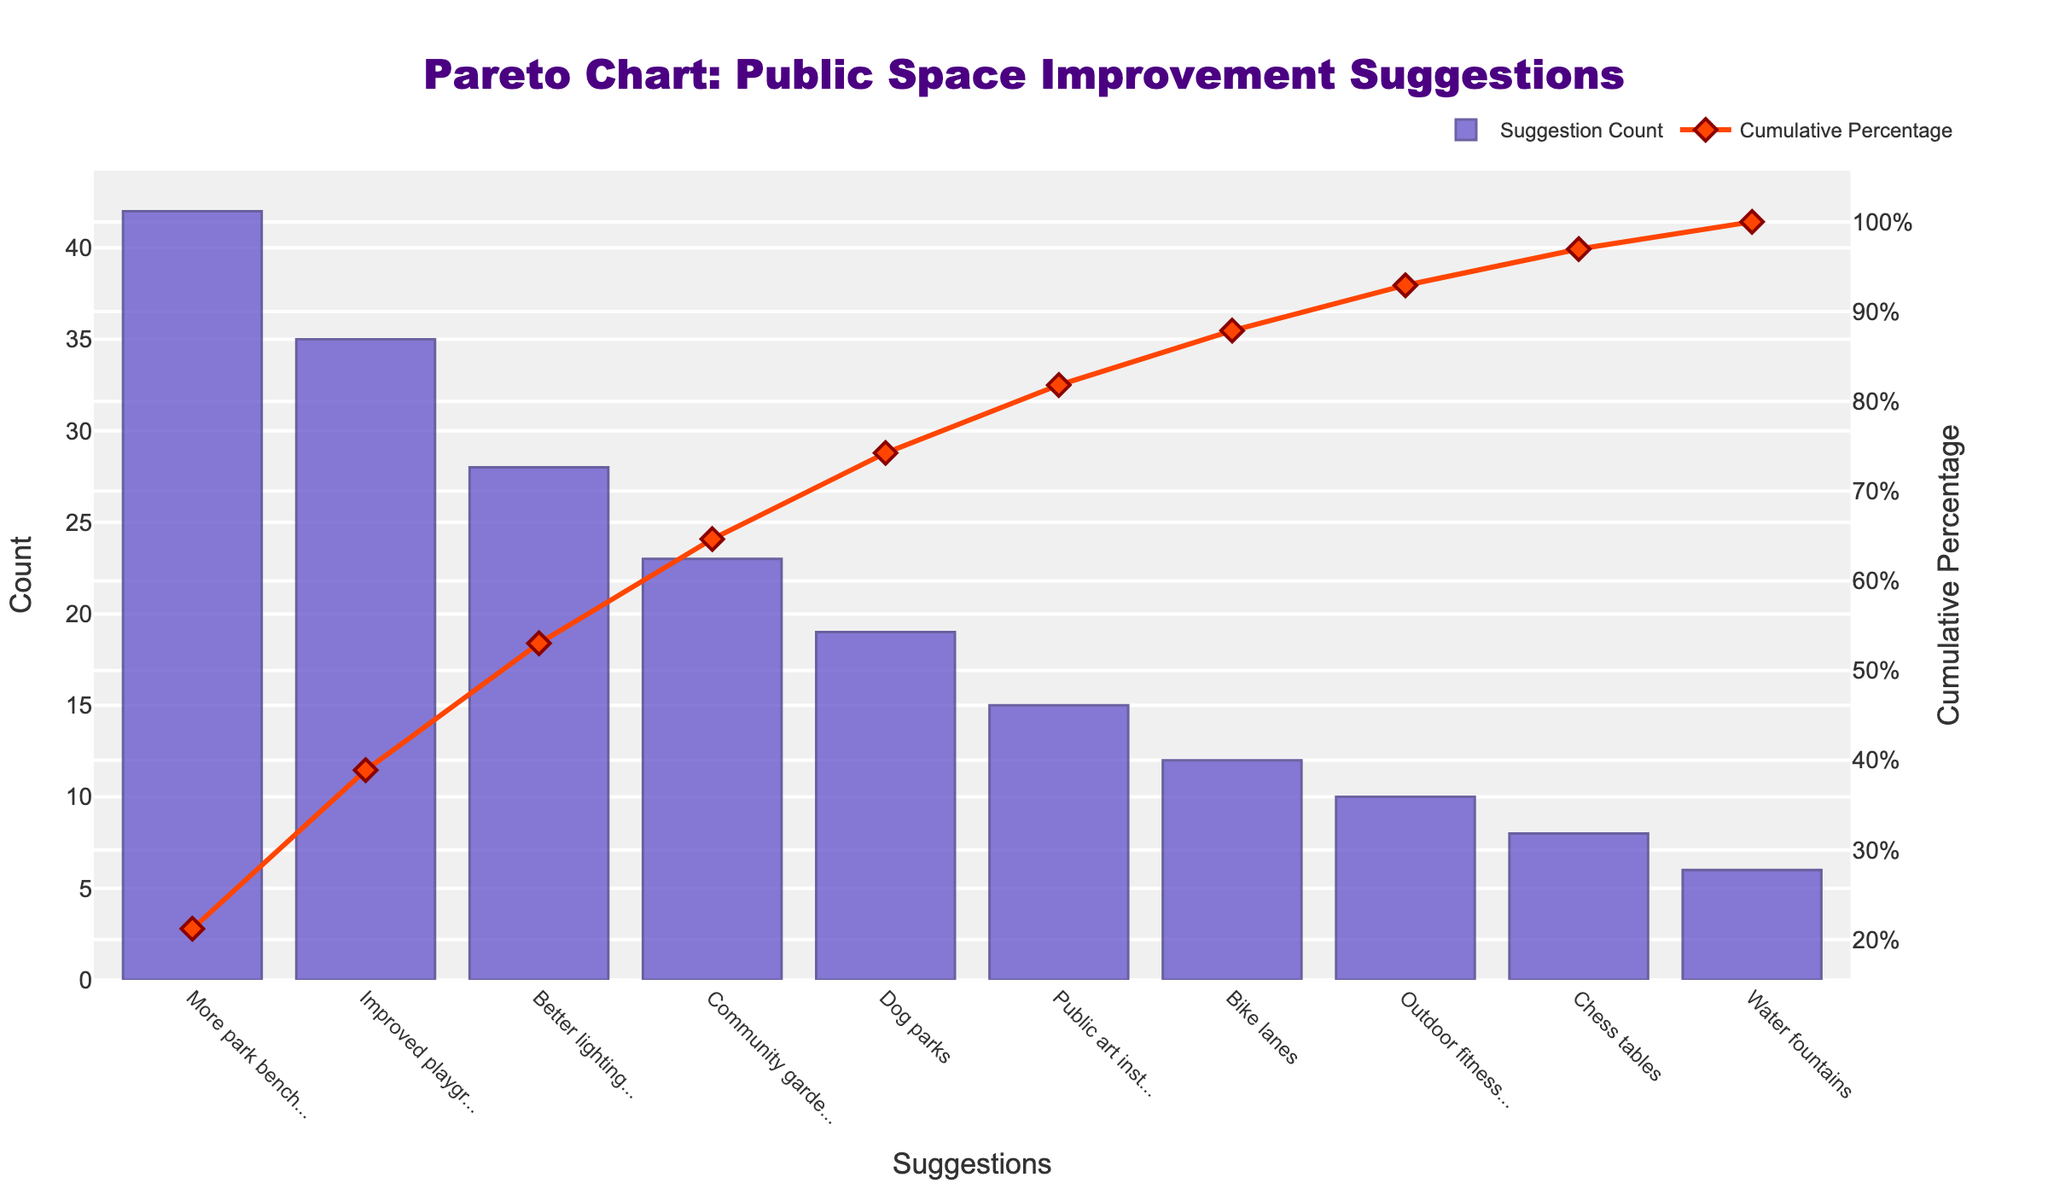What's the title of the chart? The title is displayed at the top of the chart and reads "Pareto Chart: Public Space Improvement Suggestions".
Answer: Pareto Chart: Public Space Improvement Suggestions Which suggestion received the highest number of counts? The suggestion with the highest bar on the chart represents "More park benches" with 42 counts.
Answer: More park benches What is the count for the suggestion "Improved playground equipment"? The chart shows the height of the bar for "Improved playground equipment" at 35 counts, as indicated by the y-axis.
Answer: 35 Which suggestion has the lowest count, and what is it? The bar for "Water fountains" is the shortest on the chart, corresponding to 6 counts.
Answer: Water fountains, 6 What is the cumulative percentage after including "Better lighting in public areas"? The cumulative percentage line at "Better lighting in public areas" shows approximately 63%. This is observed from the secondary y-axis on the right.
Answer: Approximately 63% How many suggestions have counts greater than or equal to 20? Observing the bars, there are three suggestions with counts greater than or equal to 20: "More park benches" (42), "Improved playground equipment" (35), and "Better lighting in public areas" (28).
Answer: 3 Which suggestions contribute to achieving the cumulative percentage of around 80%? The cumulative percentage line reaches around 80% at "Dog parks." The included suggestions are "More park benches," "Improved playground equipment," "Better lighting in public areas," "Community garden spaces," and "Dog parks."
Answer: More park benches, Improved playground equipment, Better lighting in public areas, Community garden spaces, Dog parks What is the difference in counts between "Community garden spaces" and "Public art installations"? The count for "Community garden spaces" is 23 and for "Public art installations" is 15. The difference is 23 - 15 = 8 counts.
Answer: 8 What percentage of suggestions are accounted for by "More park benches" alone? The count for "More park benches" is 42. The total count for all suggestions is 42 + 35 + 28 + 23 + 19 + 15 + 12 + 10 + 8 + 6 = 198. The percentage is (42 / 198) * 100 ≈ 21.2%.
Answer: Approximately 21.2% What is the cumulative count for the first three suggestions? The counts for "More park benches," "Improved playground equipment," and "Better lighting in public areas" are 42, 35, and 28, respectively. Cumulatively, 42 + 35 + 28 = 105.
Answer: 105 